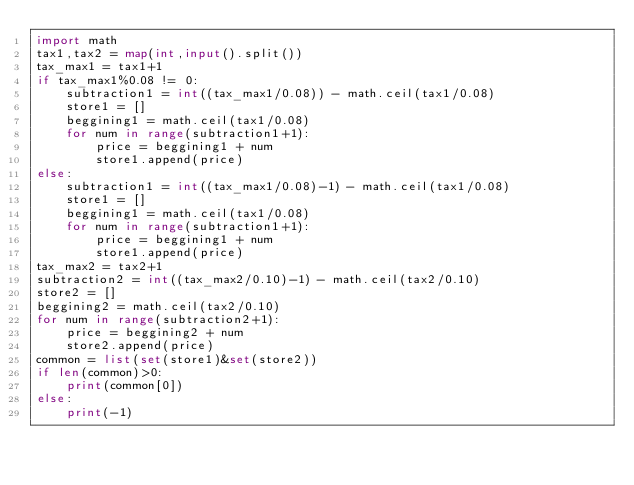<code> <loc_0><loc_0><loc_500><loc_500><_Python_>import math
tax1,tax2 = map(int,input().split())
tax_max1 = tax1+1 
if tax_max1%0.08 != 0:
    subtraction1 = int((tax_max1/0.08)) - math.ceil(tax1/0.08)
    store1 = []
    beggining1 = math.ceil(tax1/0.08)
    for num in range(subtraction1+1):
        price = beggining1 + num
        store1.append(price)
else:
    subtraction1 = int((tax_max1/0.08)-1) - math.ceil(tax1/0.08)
    store1 = []
    beggining1 = math.ceil(tax1/0.08)
    for num in range(subtraction1+1):
        price = beggining1 + num
        store1.append(price)
tax_max2 = tax2+1
subtraction2 = int((tax_max2/0.10)-1) - math.ceil(tax2/0.10)
store2 = []
beggining2 = math.ceil(tax2/0.10)
for num in range(subtraction2+1):
    price = beggining2 + num
    store2.append(price)
common = list(set(store1)&set(store2))
if len(common)>0:
    print(common[0])
else:
    print(-1)</code> 